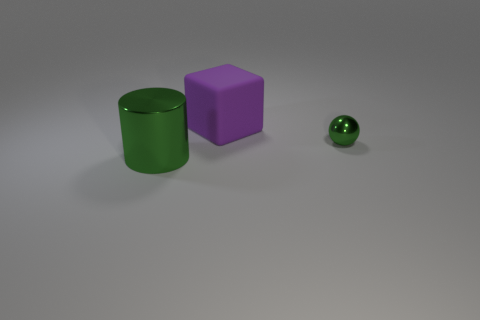Add 1 tiny shiny spheres. How many objects exist? 4 Subtract all gray cylinders. Subtract all yellow balls. How many cylinders are left? 1 Subtract all cubes. How many objects are left? 2 Add 1 green cylinders. How many green cylinders exist? 2 Subtract 0 green cubes. How many objects are left? 3 Subtract all rubber blocks. Subtract all small shiny balls. How many objects are left? 1 Add 1 metal spheres. How many metal spheres are left? 2 